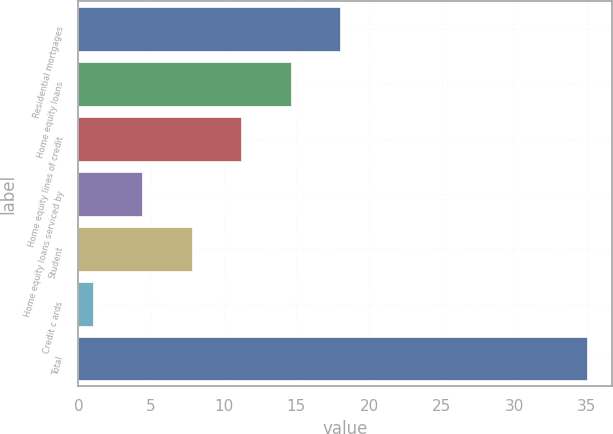Convert chart. <chart><loc_0><loc_0><loc_500><loc_500><bar_chart><fcel>Residential mortgages<fcel>Home equity loans<fcel>Home equity lines of credit<fcel>Home equity loans serviced by<fcel>Student<fcel>Credit c ards<fcel>Total<nl><fcel>18<fcel>14.6<fcel>11.2<fcel>4.4<fcel>7.8<fcel>1<fcel>35<nl></chart> 